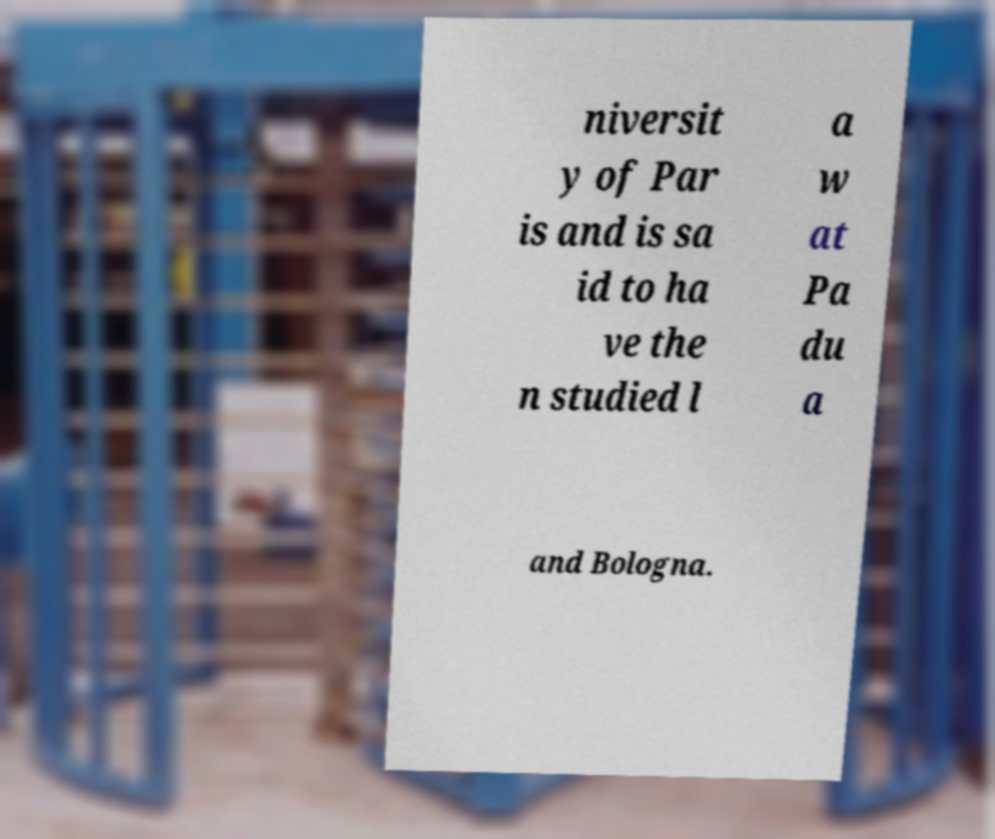Could you assist in decoding the text presented in this image and type it out clearly? niversit y of Par is and is sa id to ha ve the n studied l a w at Pa du a and Bologna. 